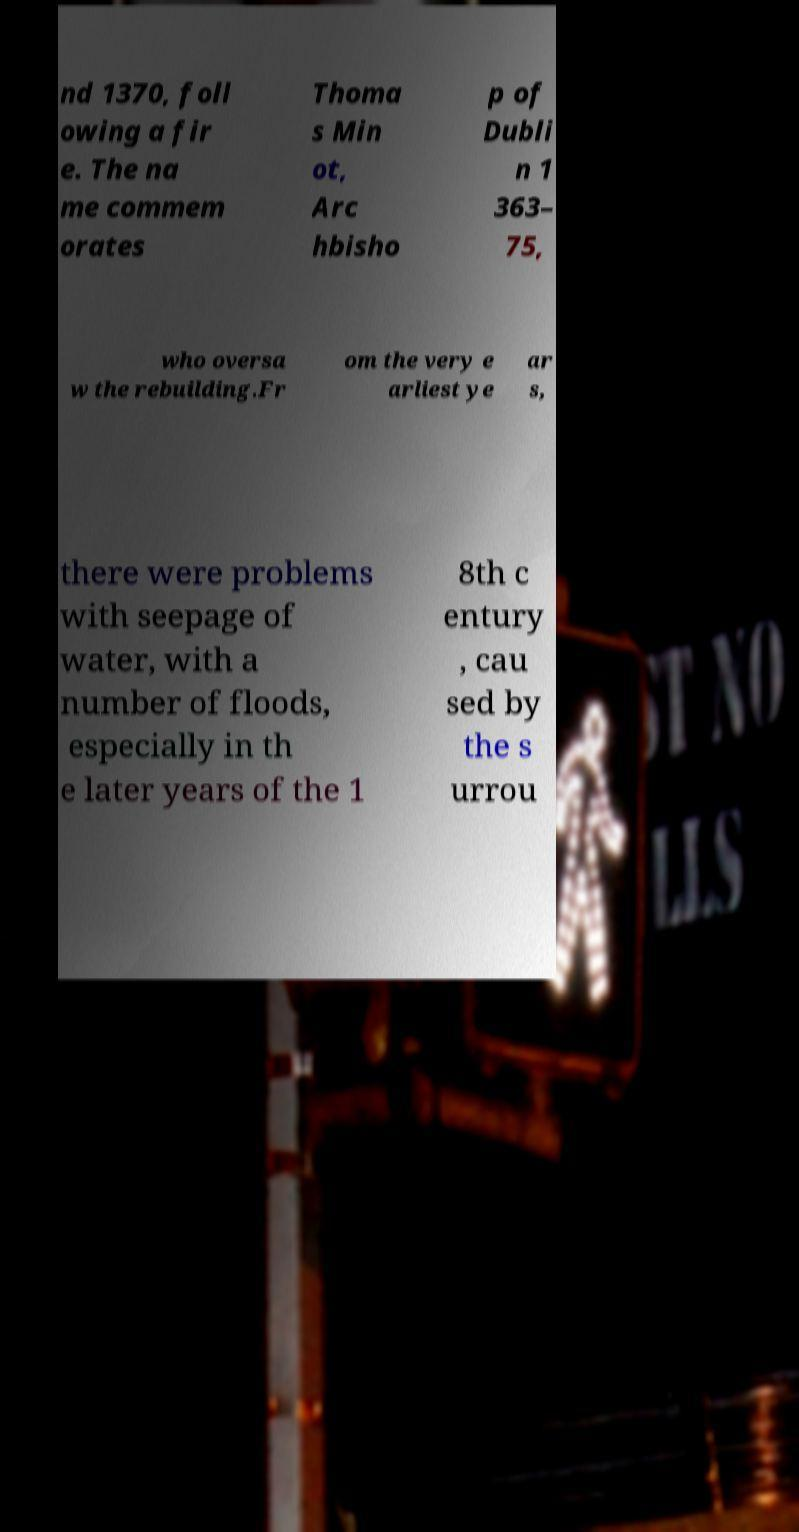There's text embedded in this image that I need extracted. Can you transcribe it verbatim? nd 1370, foll owing a fir e. The na me commem orates Thoma s Min ot, Arc hbisho p of Dubli n 1 363– 75, who oversa w the rebuilding.Fr om the very e arliest ye ar s, there were problems with seepage of water, with a number of floods, especially in th e later years of the 1 8th c entury , cau sed by the s urrou 